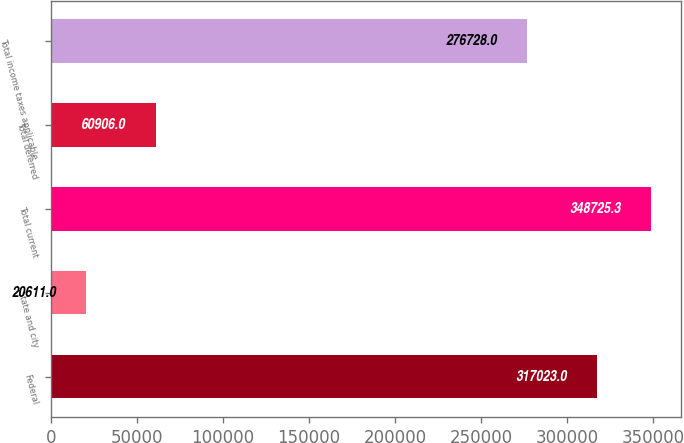<chart> <loc_0><loc_0><loc_500><loc_500><bar_chart><fcel>Federal<fcel>State and city<fcel>Total current<fcel>Total deferred<fcel>Total income taxes applicable<nl><fcel>317023<fcel>20611<fcel>348725<fcel>60906<fcel>276728<nl></chart> 